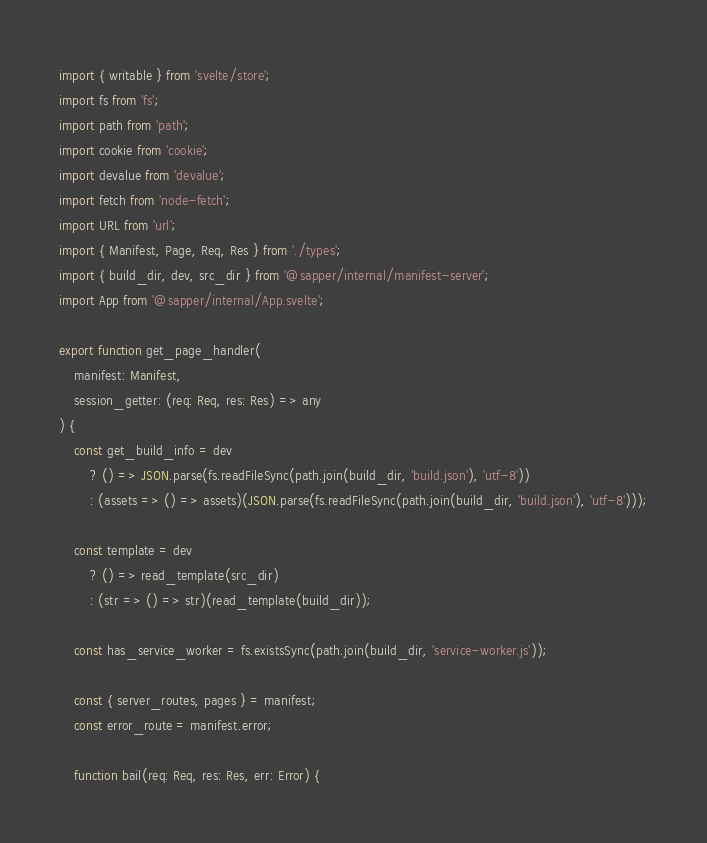<code> <loc_0><loc_0><loc_500><loc_500><_TypeScript_>import { writable } from 'svelte/store';
import fs from 'fs';
import path from 'path';
import cookie from 'cookie';
import devalue from 'devalue';
import fetch from 'node-fetch';
import URL from 'url';
import { Manifest, Page, Req, Res } from './types';
import { build_dir, dev, src_dir } from '@sapper/internal/manifest-server';
import App from '@sapper/internal/App.svelte';

export function get_page_handler(
	manifest: Manifest,
	session_getter: (req: Req, res: Res) => any
) {
	const get_build_info = dev
		? () => JSON.parse(fs.readFileSync(path.join(build_dir, 'build.json'), 'utf-8'))
		: (assets => () => assets)(JSON.parse(fs.readFileSync(path.join(build_dir, 'build.json'), 'utf-8')));

	const template = dev
		? () => read_template(src_dir)
		: (str => () => str)(read_template(build_dir));

	const has_service_worker = fs.existsSync(path.join(build_dir, 'service-worker.js'));

	const { server_routes, pages } = manifest;
	const error_route = manifest.error;

	function bail(req: Req, res: Res, err: Error) {</code> 